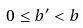<formula> <loc_0><loc_0><loc_500><loc_500>0 \leq b ^ { \prime } < b</formula> 